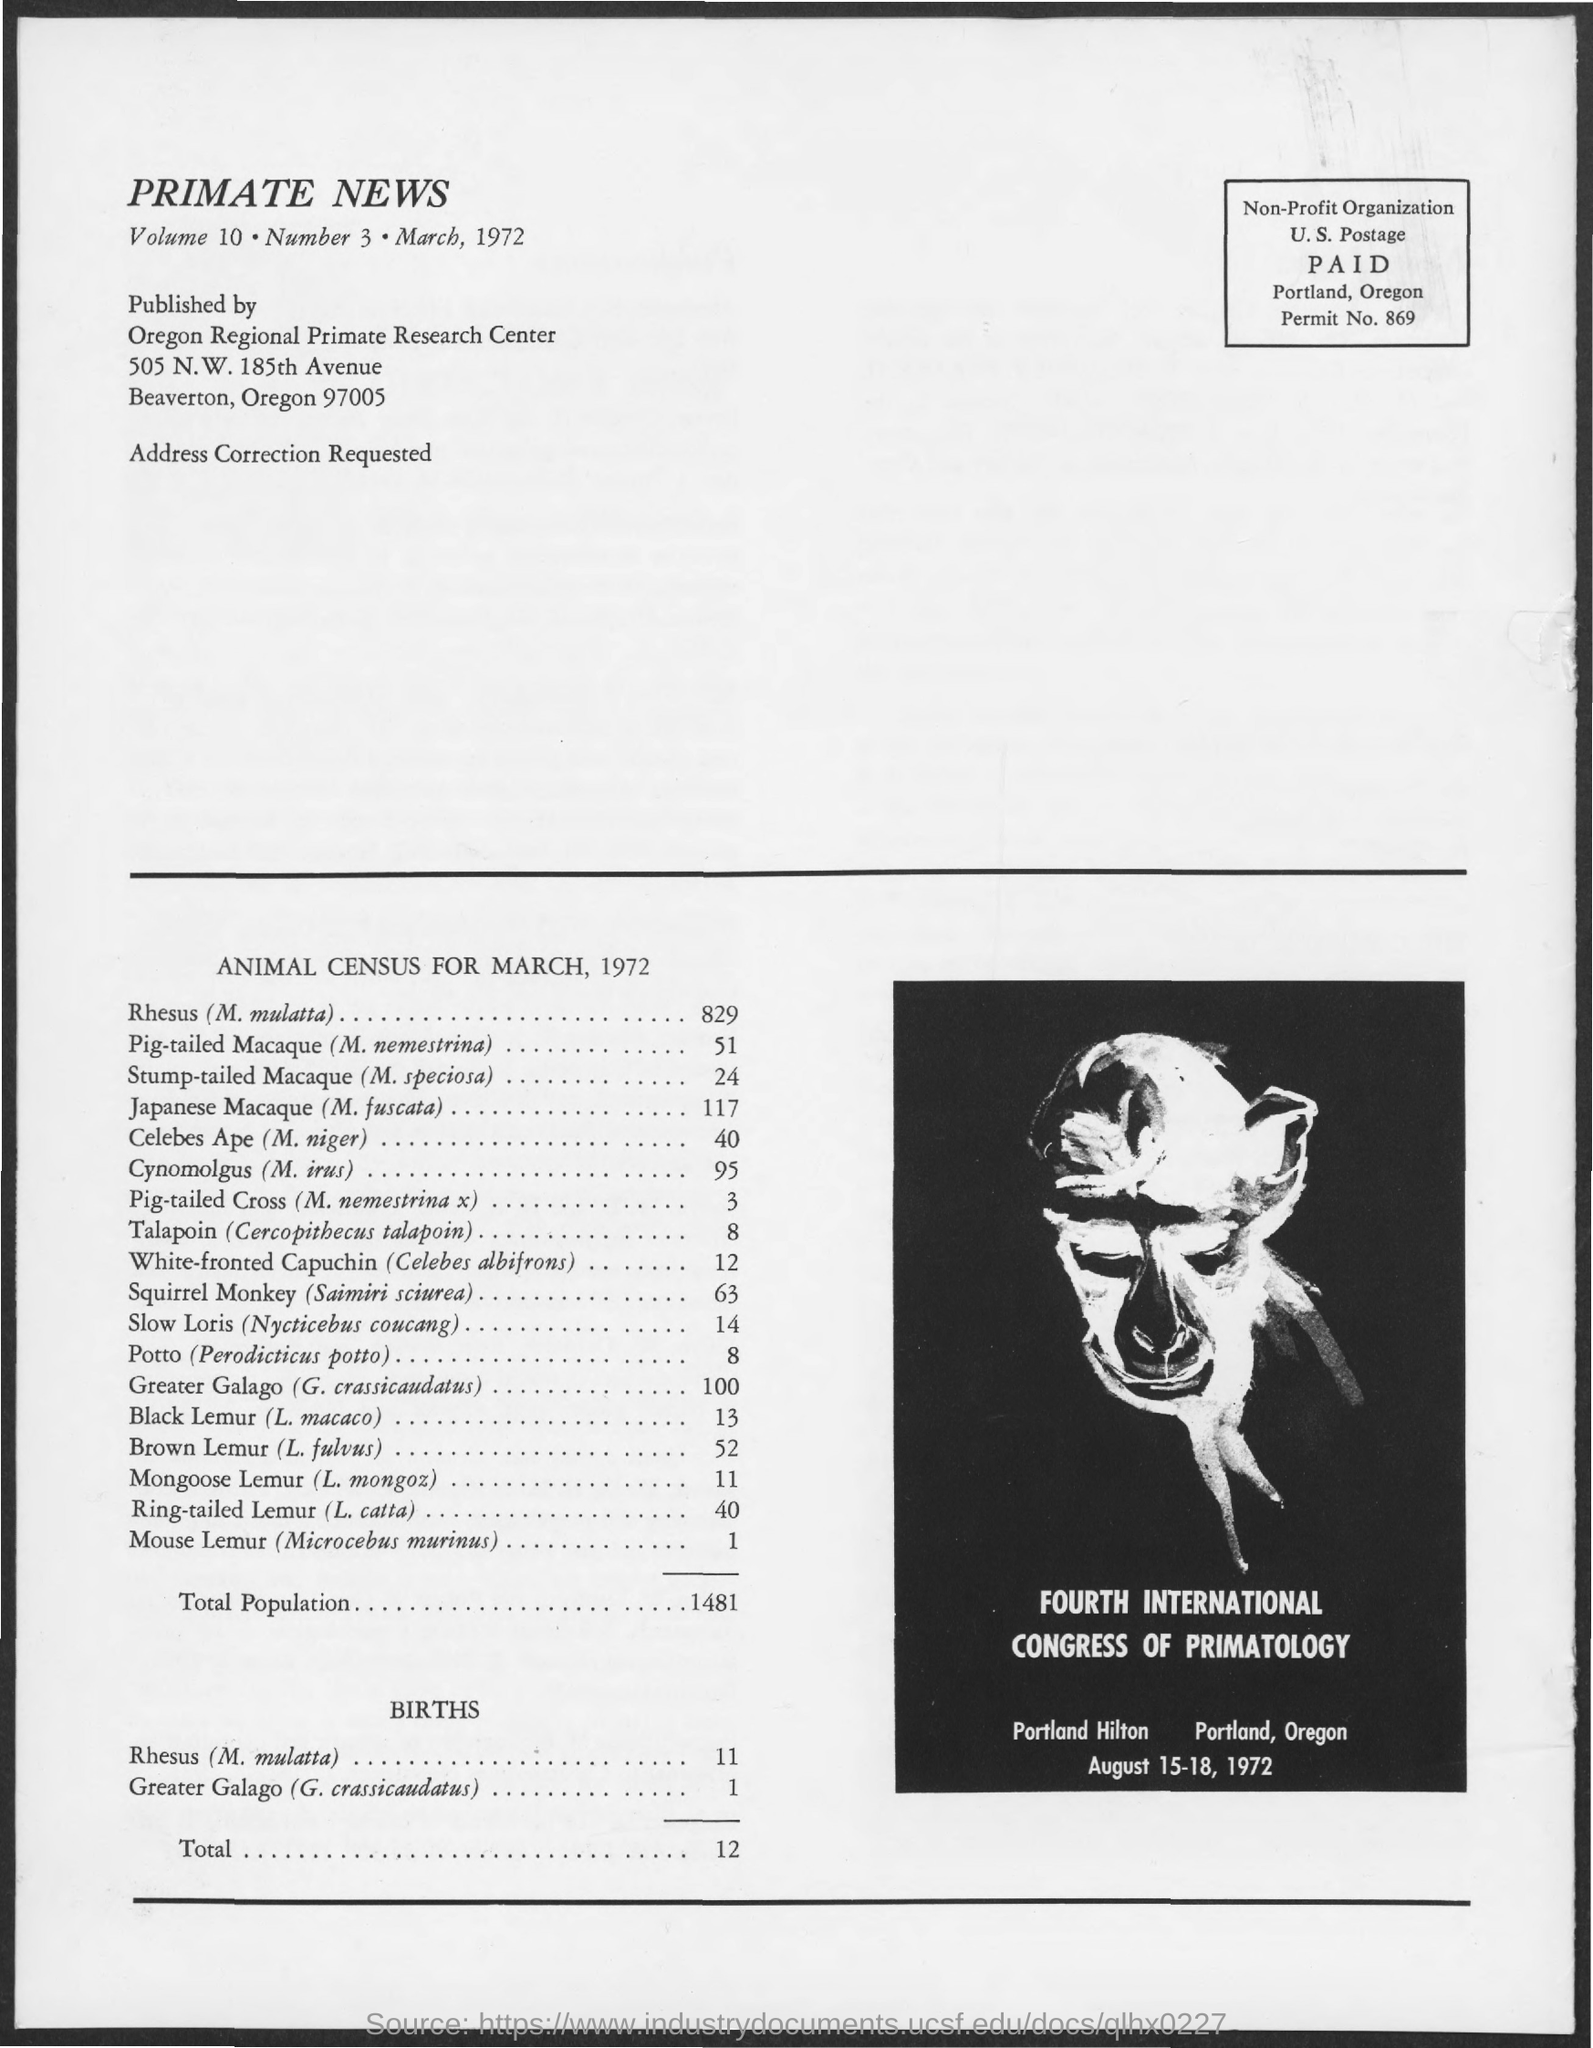When was the Fourth International Congress of Primatology held?
Offer a very short reply. August 15-18, 1972. What is the Permit No given in this document?
Give a very brief answer. 869. What is the total population as per the animal census for March, 1972?
Provide a succinct answer. 1481. What is the total no of births as per the animal census for March, 1972?
Give a very brief answer. 12. What is the census of Rhesus (M. mulatta) as per the document?
Keep it short and to the point. 829. What is the census of Cynomolgus (M. irus) as per the document?
Ensure brevity in your answer.  95. 